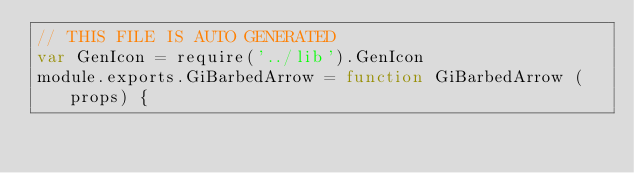Convert code to text. <code><loc_0><loc_0><loc_500><loc_500><_JavaScript_>// THIS FILE IS AUTO GENERATED
var GenIcon = require('../lib').GenIcon
module.exports.GiBarbedArrow = function GiBarbedArrow (props) {</code> 